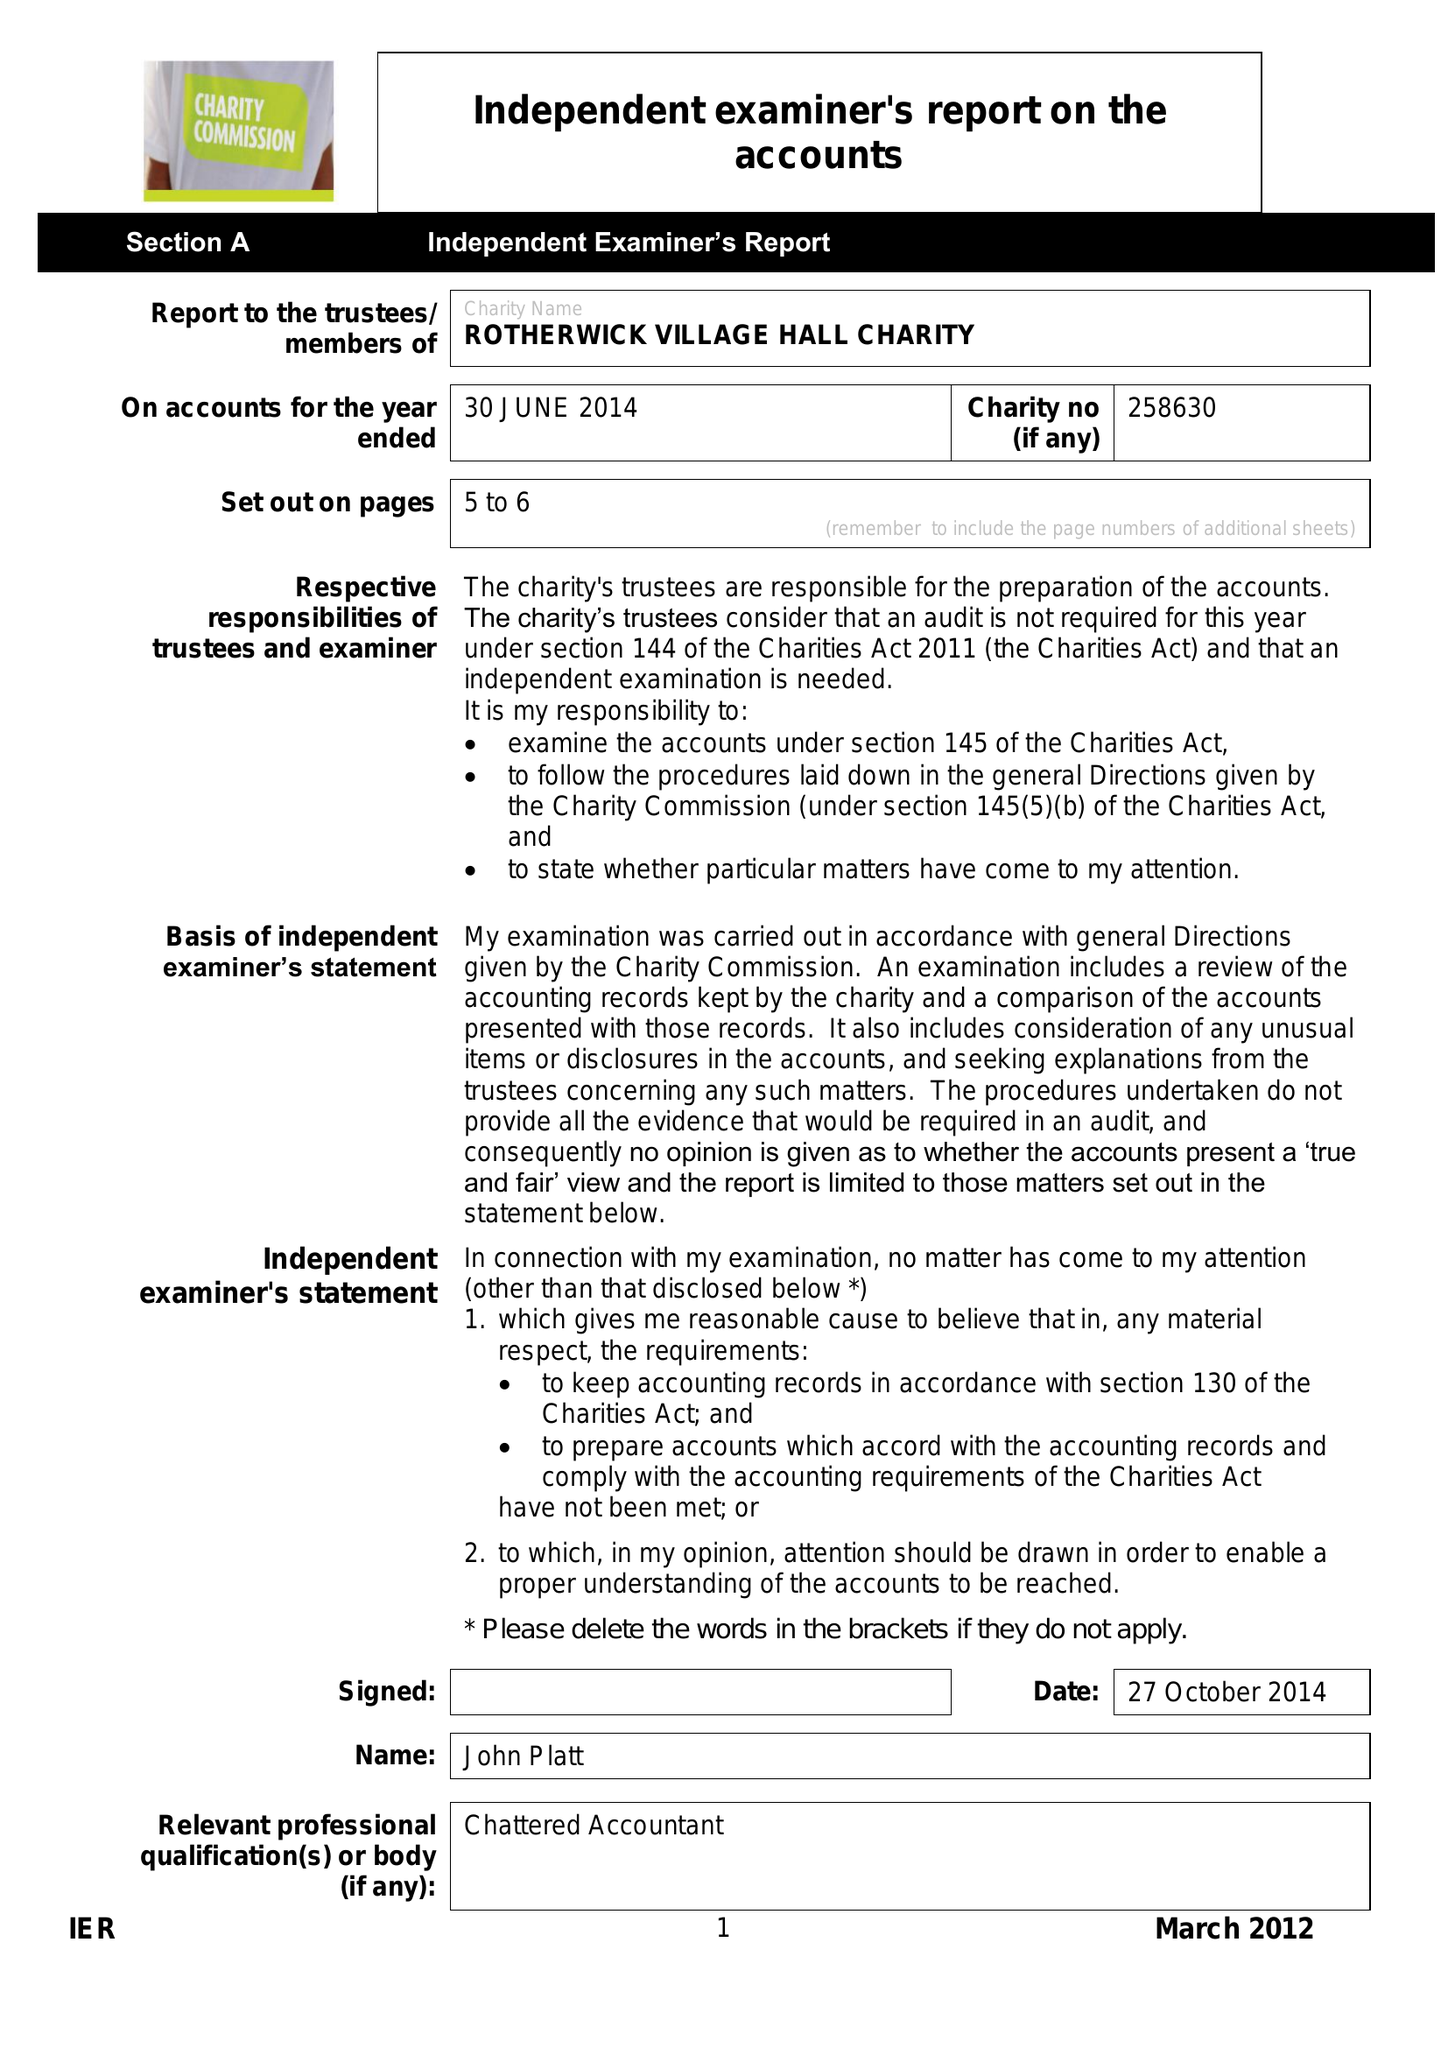What is the value for the charity_name?
Answer the question using a single word or phrase. Rotherwick Village Hall Charity 